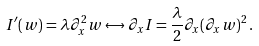Convert formula to latex. <formula><loc_0><loc_0><loc_500><loc_500>I ^ { \prime } ( w ) = \lambda \partial _ { x } ^ { 2 } w \leftrightarrow \partial _ { x } I = \frac { \lambda } { 2 } \partial _ { x } ( \partial _ { x } w ) ^ { 2 } \, .</formula> 